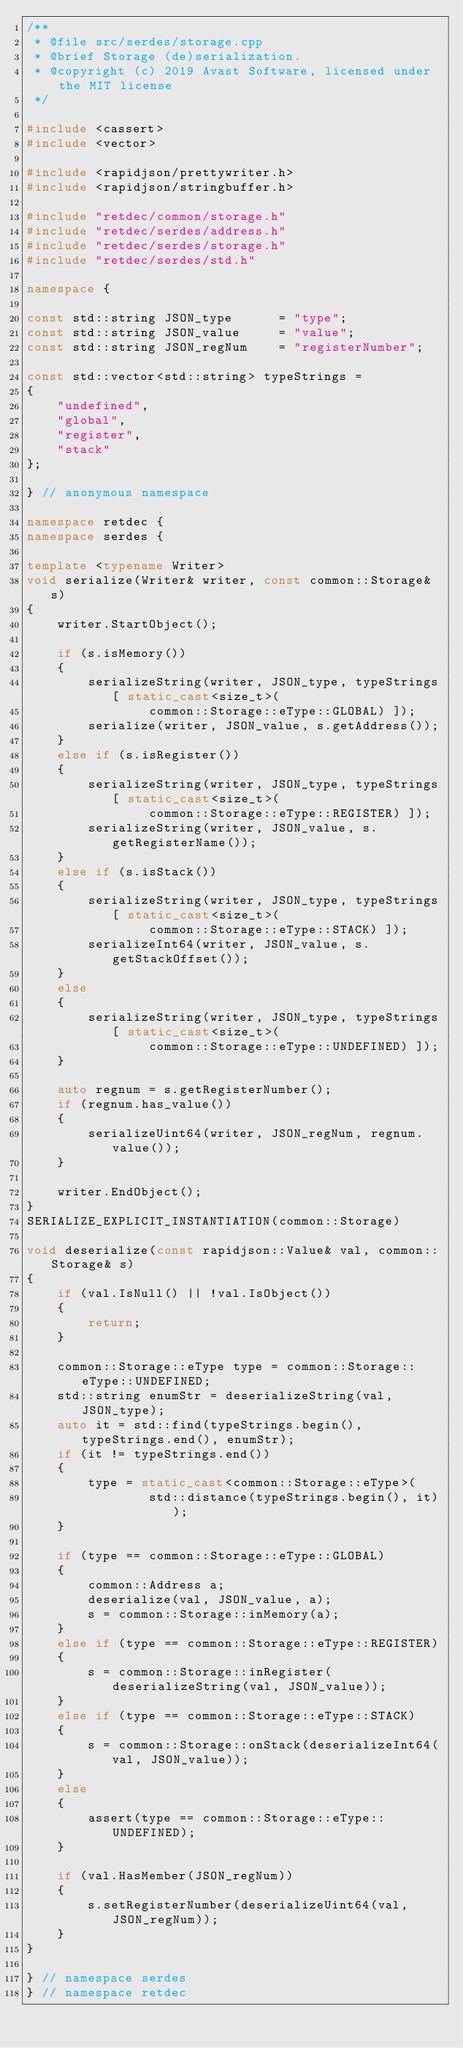<code> <loc_0><loc_0><loc_500><loc_500><_C++_>/**
 * @file src/serdes/storage.cpp
 * @brief Storage (de)serialization.
 * @copyright (c) 2019 Avast Software, licensed under the MIT license
 */

#include <cassert>
#include <vector>

#include <rapidjson/prettywriter.h>
#include <rapidjson/stringbuffer.h>

#include "retdec/common/storage.h"
#include "retdec/serdes/address.h"
#include "retdec/serdes/storage.h"
#include "retdec/serdes/std.h"

namespace {

const std::string JSON_type      = "type";
const std::string JSON_value     = "value";
const std::string JSON_regNum    = "registerNumber";

const std::vector<std::string> typeStrings =
{
	"undefined",
	"global",
	"register",
	"stack"
};

} // anonymous namespace

namespace retdec {
namespace serdes {

template <typename Writer>
void serialize(Writer& writer, const common::Storage& s)
{
	writer.StartObject();

	if (s.isMemory())
	{
		serializeString(writer, JSON_type, typeStrings[ static_cast<size_t>(
				common::Storage::eType::GLOBAL) ]);
		serialize(writer, JSON_value, s.getAddress());
	}
	else if (s.isRegister())
	{
		serializeString(writer, JSON_type, typeStrings[ static_cast<size_t>(
				common::Storage::eType::REGISTER) ]);
		serializeString(writer, JSON_value, s.getRegisterName());
	}
	else if (s.isStack())
	{
		serializeString(writer, JSON_type, typeStrings[ static_cast<size_t>(
				common::Storage::eType::STACK) ]);
		serializeInt64(writer, JSON_value, s.getStackOffset());
	}
	else
	{
		serializeString(writer, JSON_type, typeStrings[ static_cast<size_t>(
				common::Storage::eType::UNDEFINED) ]);
	}

	auto regnum = s.getRegisterNumber();
	if (regnum.has_value())
	{
		serializeUint64(writer, JSON_regNum, regnum.value());
	}

	writer.EndObject();
}
SERIALIZE_EXPLICIT_INSTANTIATION(common::Storage)

void deserialize(const rapidjson::Value& val, common::Storage& s)
{
	if (val.IsNull() || !val.IsObject())
	{
		return;
	}

	common::Storage::eType type = common::Storage::eType::UNDEFINED;
	std::string enumStr = deserializeString(val, JSON_type);
	auto it = std::find(typeStrings.begin(), typeStrings.end(), enumStr);
	if (it != typeStrings.end())
	{
		type = static_cast<common::Storage::eType>(
				std::distance(typeStrings.begin(), it));
	}

	if (type == common::Storage::eType::GLOBAL)
	{
		common::Address a;
		deserialize(val, JSON_value, a);
		s = common::Storage::inMemory(a);
	}
	else if (type == common::Storage::eType::REGISTER)
	{
		s = common::Storage::inRegister(deserializeString(val, JSON_value));
	}
	else if (type == common::Storage::eType::STACK)
	{
		s = common::Storage::onStack(deserializeInt64(val, JSON_value));
	}
	else
	{
		assert(type == common::Storage::eType::UNDEFINED);
	}

	if (val.HasMember(JSON_regNum))
	{
		s.setRegisterNumber(deserializeUint64(val, JSON_regNum));
	}
}

} // namespace serdes
} // namespace retdec
</code> 